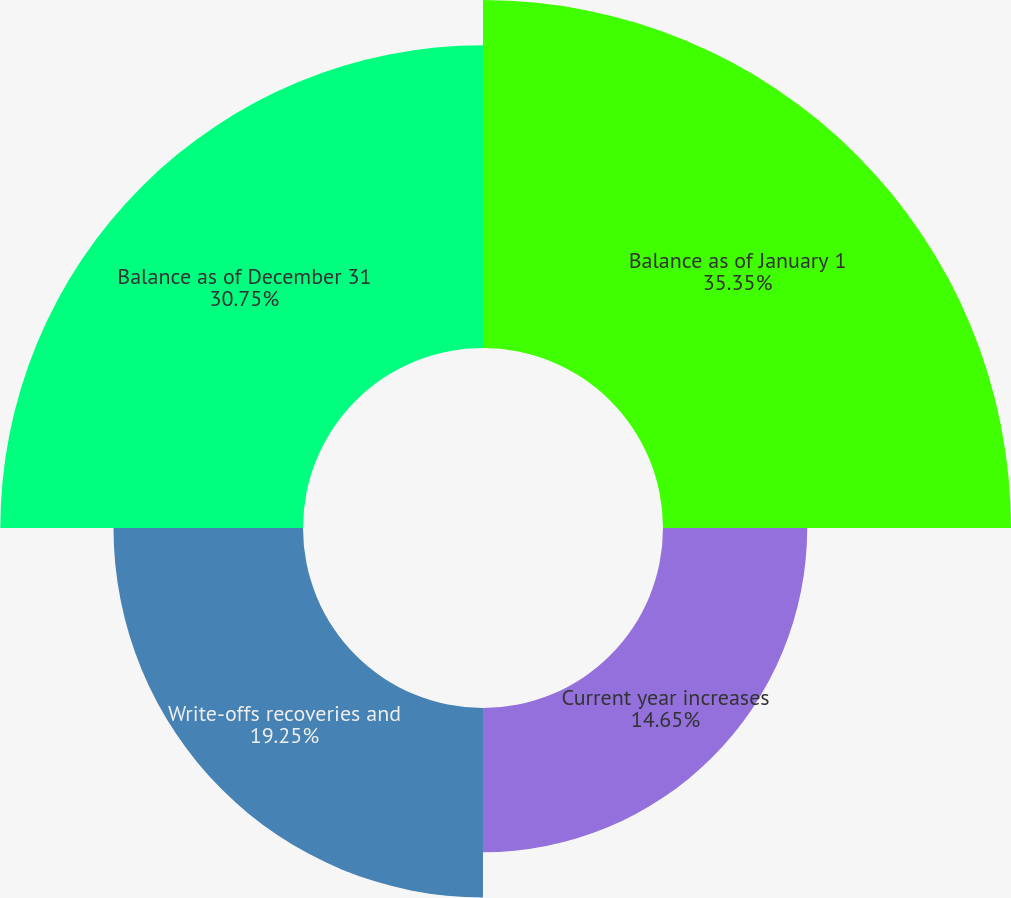Convert chart. <chart><loc_0><loc_0><loc_500><loc_500><pie_chart><fcel>Balance as of January 1<fcel>Current year increases<fcel>Write-offs recoveries and<fcel>Balance as of December 31<nl><fcel>35.35%<fcel>14.65%<fcel>19.25%<fcel>30.75%<nl></chart> 